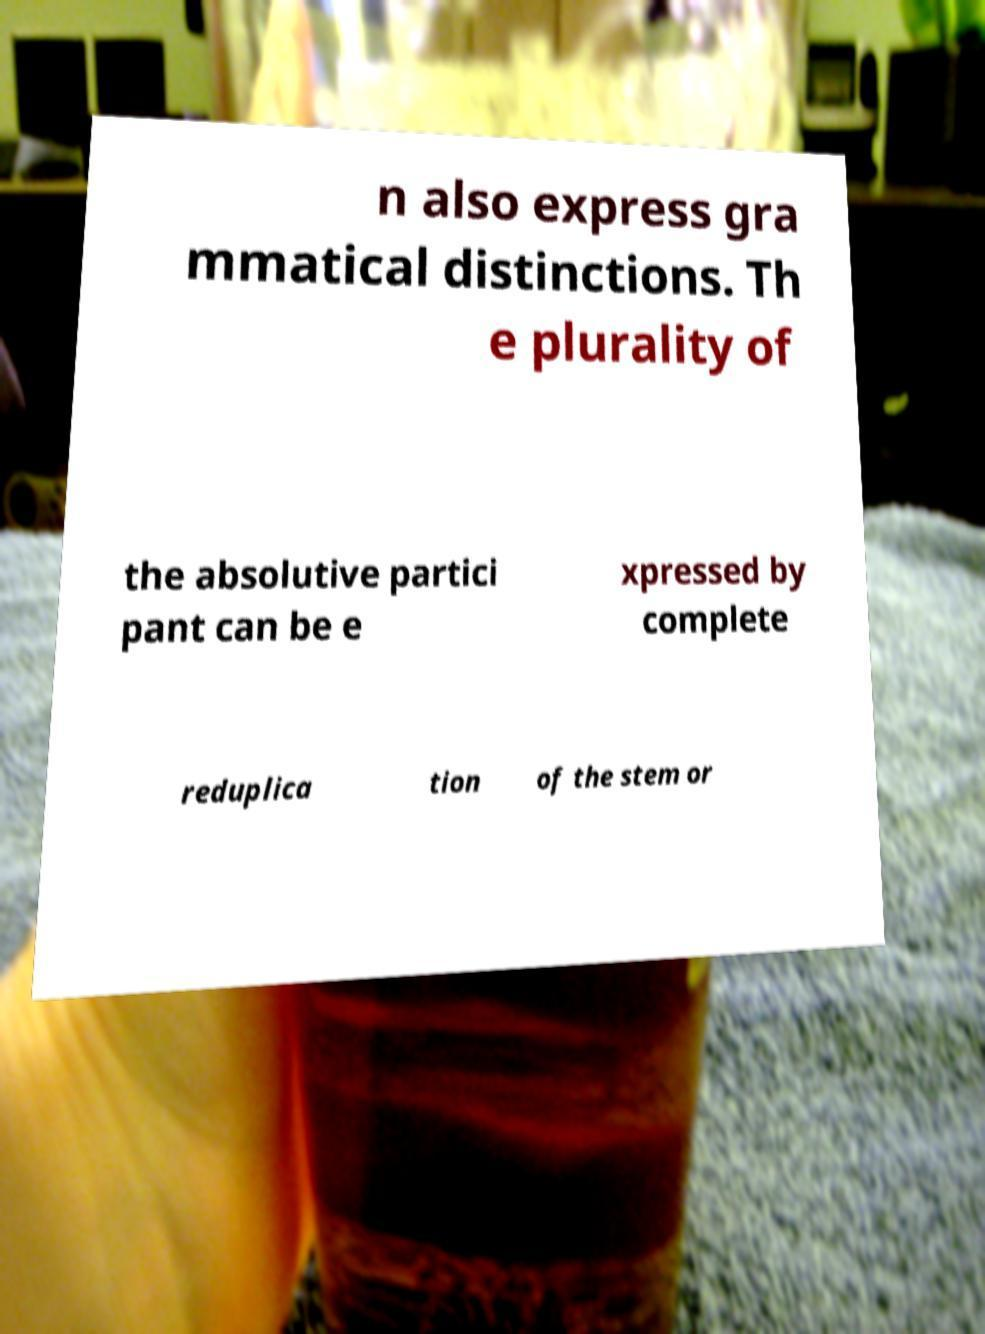Could you assist in decoding the text presented in this image and type it out clearly? n also express gra mmatical distinctions. Th e plurality of the absolutive partici pant can be e xpressed by complete reduplica tion of the stem or 